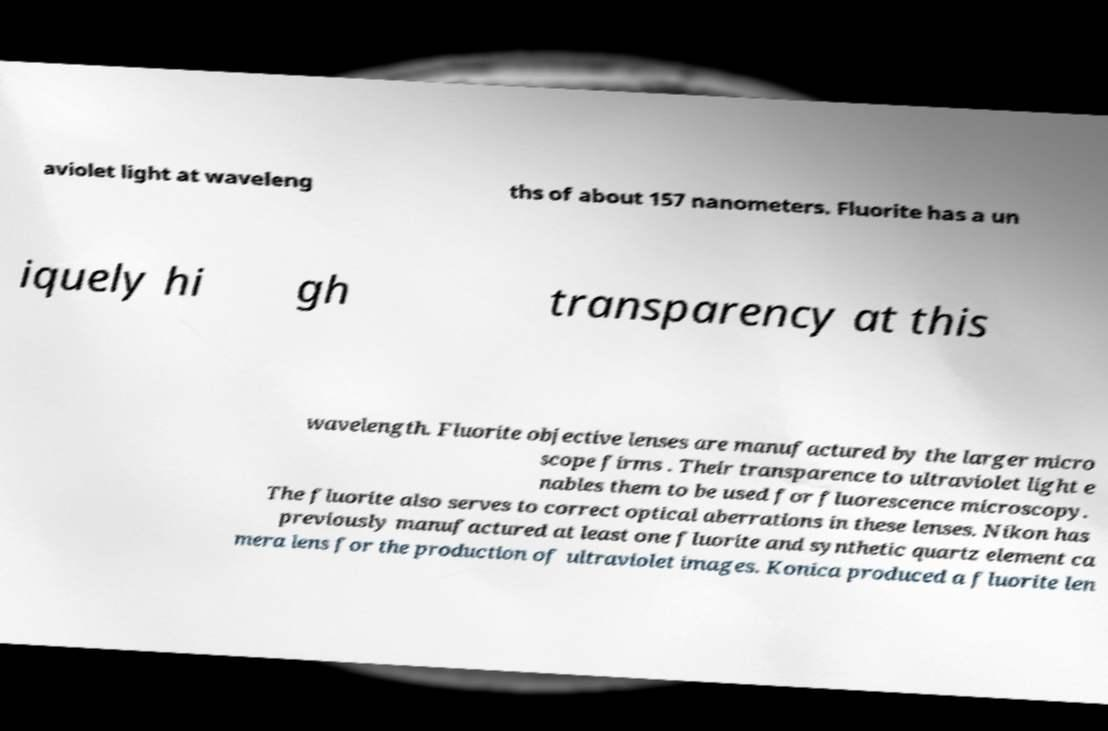There's text embedded in this image that I need extracted. Can you transcribe it verbatim? aviolet light at waveleng ths of about 157 nanometers. Fluorite has a un iquely hi gh transparency at this wavelength. Fluorite objective lenses are manufactured by the larger micro scope firms . Their transparence to ultraviolet light e nables them to be used for fluorescence microscopy. The fluorite also serves to correct optical aberrations in these lenses. Nikon has previously manufactured at least one fluorite and synthetic quartz element ca mera lens for the production of ultraviolet images. Konica produced a fluorite len 